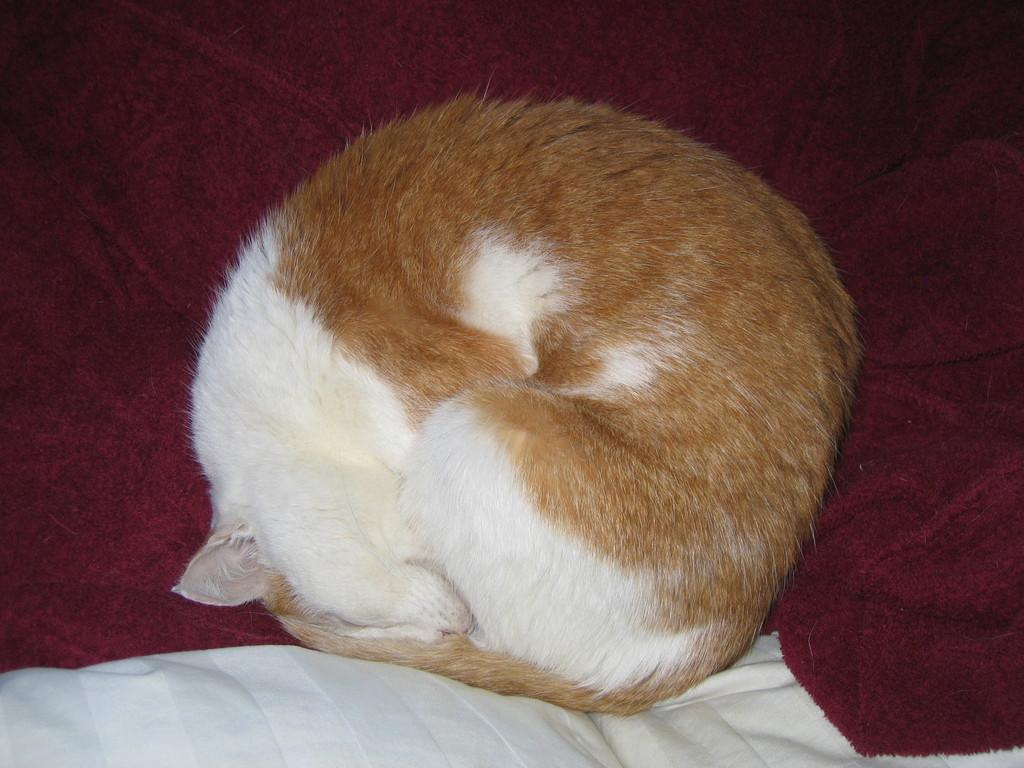What type of animal is present in the image? There is a cat in the image. What else can be seen in the image besides the cat? There are clothes in the image. Where is the rabbit hiding in the image? There is no rabbit present in the image. What type of pie is being served in the image? There is no pie present in the image. 